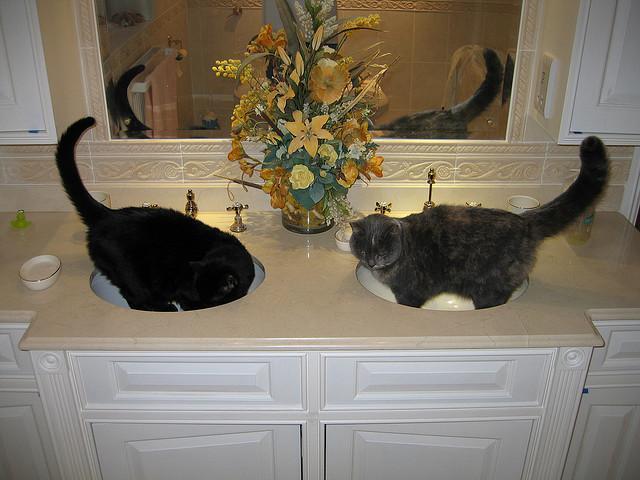Where are the cats playing?
From the following four choices, select the correct answer to address the question.
Options: Sink, sand, river, parking lot. Sink. 